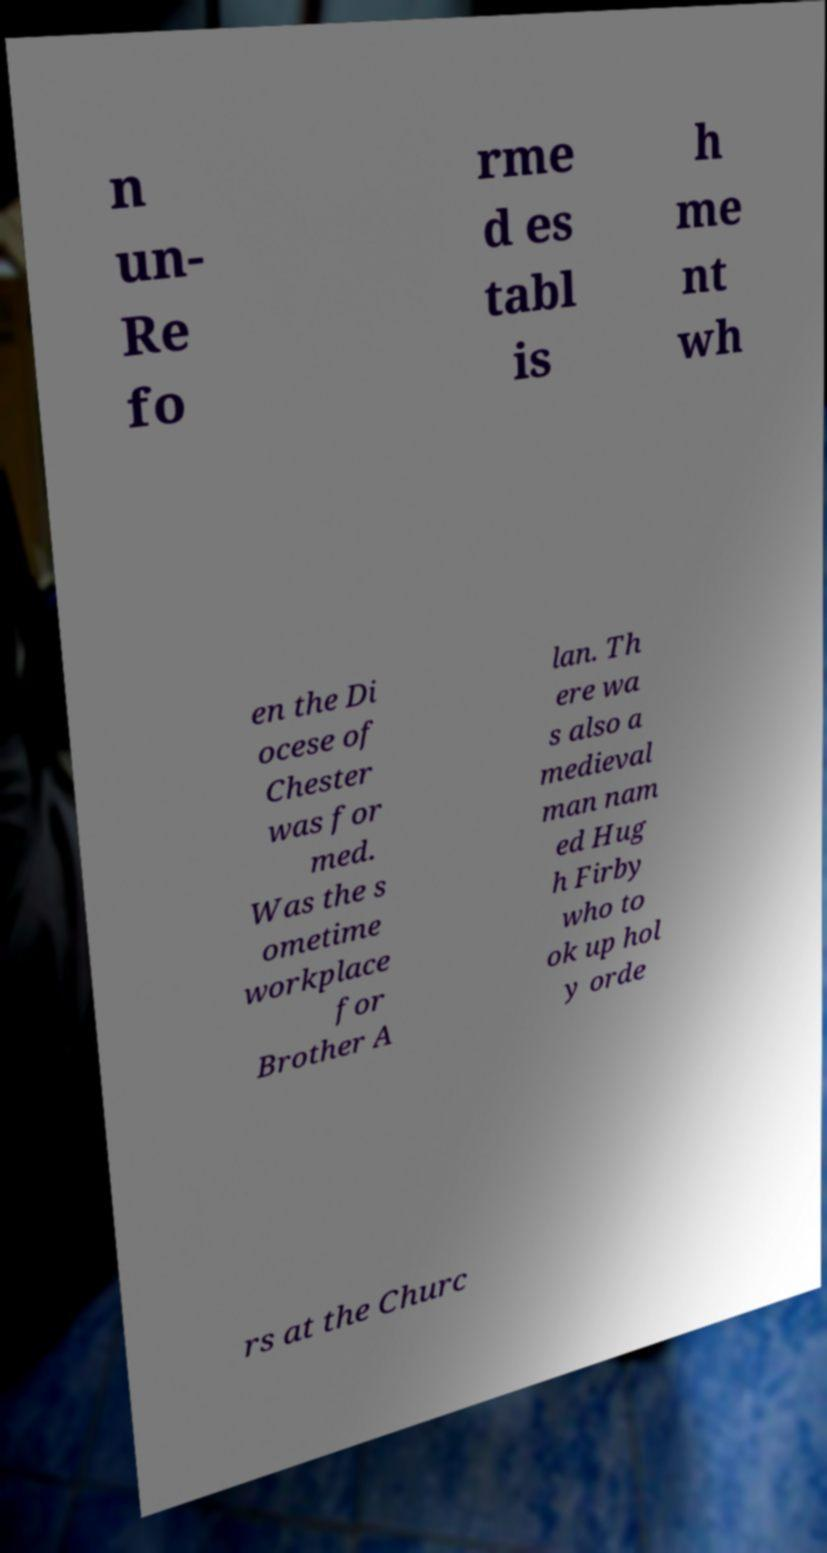I need the written content from this picture converted into text. Can you do that? n un- Re fo rme d es tabl is h me nt wh en the Di ocese of Chester was for med. Was the s ometime workplace for Brother A lan. Th ere wa s also a medieval man nam ed Hug h Firby who to ok up hol y orde rs at the Churc 